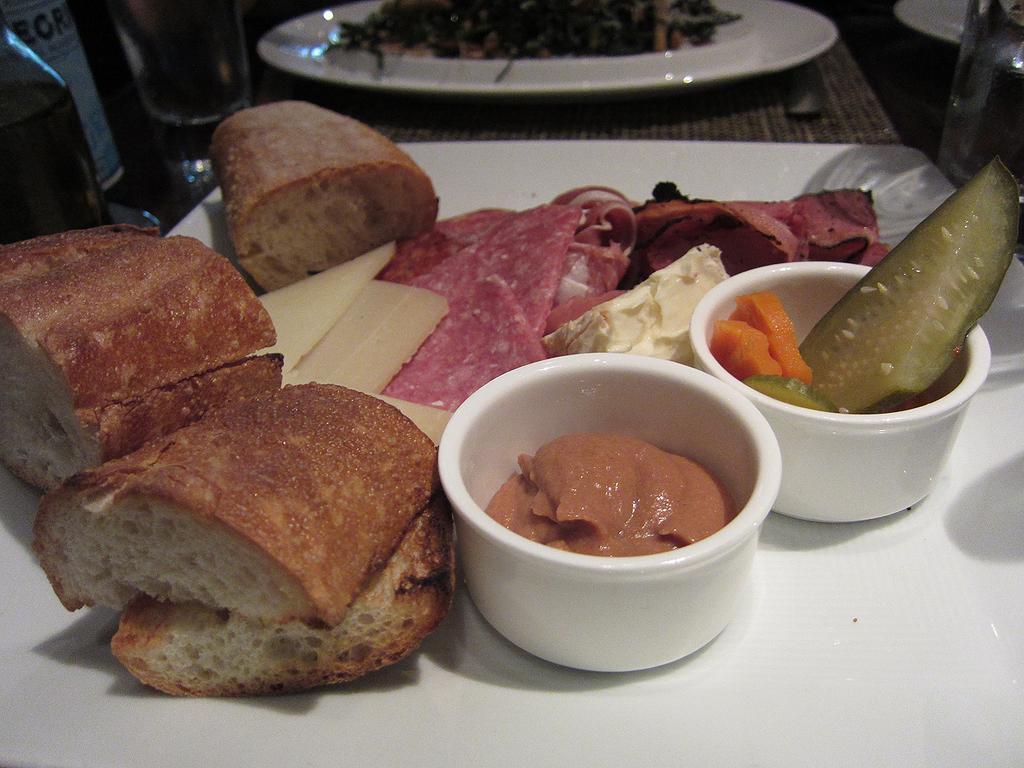Please provide a concise description of this image. In this picture, we see a white table in which food, meat, cheese, a bowl containing cream, a bowl containing carrots and cucumber are placed. Beside that, we see a table on which a plate containing food are placed. This picture might be clicked in the hotel. 